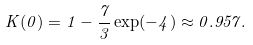<formula> <loc_0><loc_0><loc_500><loc_500>K ( 0 ) = 1 - \frac { 7 } { 3 } \exp ( - 4 ) \approx 0 . 9 5 7 .</formula> 